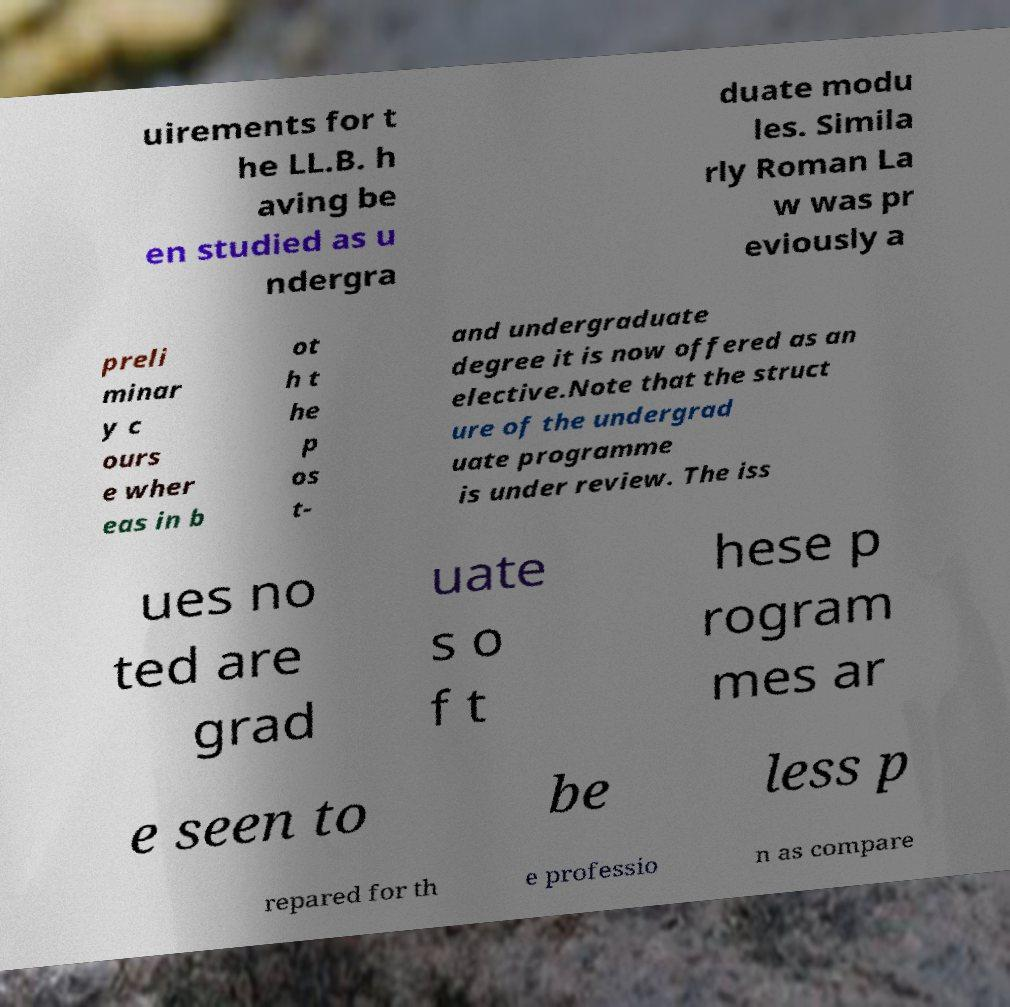I need the written content from this picture converted into text. Can you do that? uirements for t he LL.B. h aving be en studied as u ndergra duate modu les. Simila rly Roman La w was pr eviously a preli minar y c ours e wher eas in b ot h t he p os t- and undergraduate degree it is now offered as an elective.Note that the struct ure of the undergrad uate programme is under review. The iss ues no ted are grad uate s o f t hese p rogram mes ar e seen to be less p repared for th e professio n as compare 